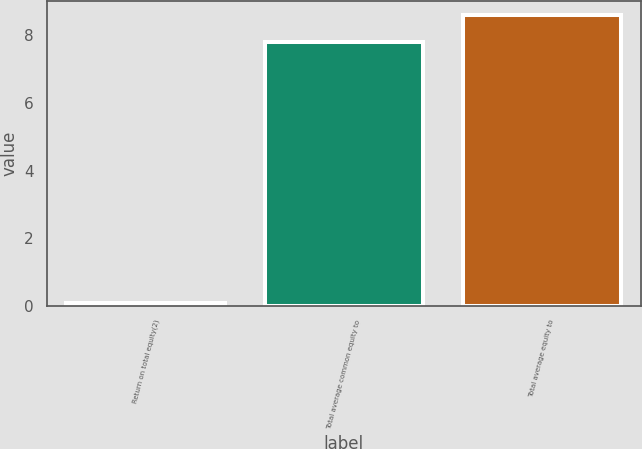Convert chart to OTSL. <chart><loc_0><loc_0><loc_500><loc_500><bar_chart><fcel>Return on total equity(2)<fcel>Total average common equity to<fcel>Total average equity to<nl><fcel>0.1<fcel>7.8<fcel>8.59<nl></chart> 